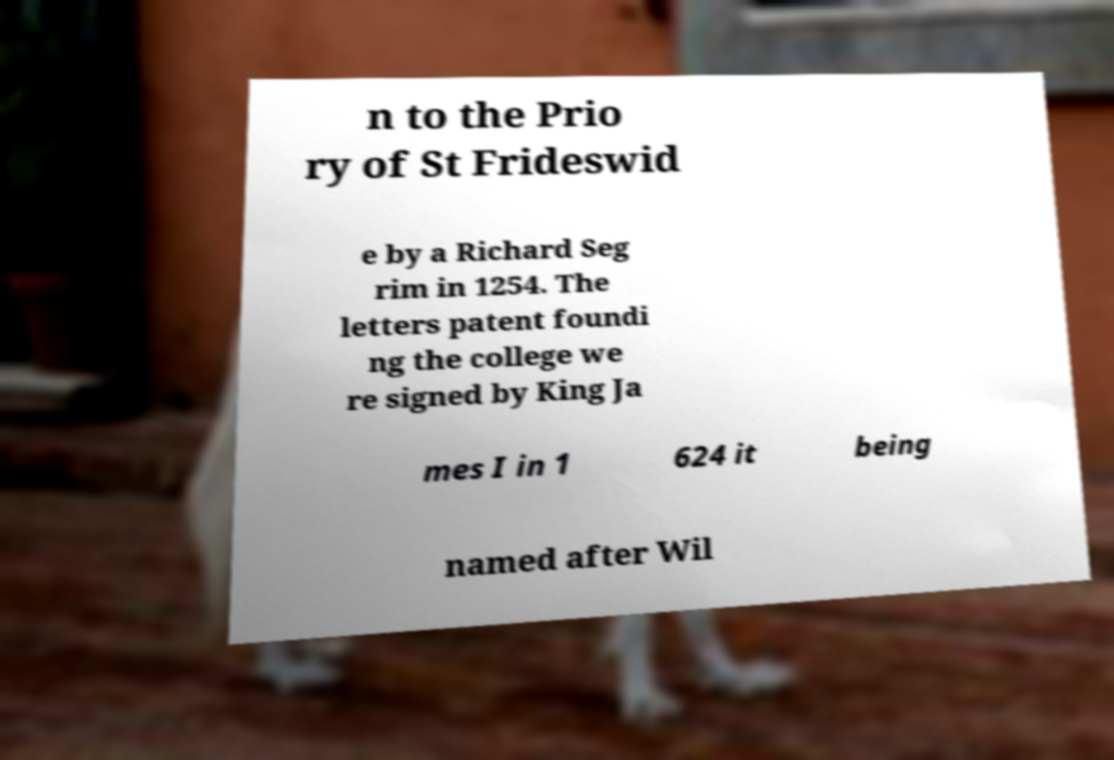There's text embedded in this image that I need extracted. Can you transcribe it verbatim? n to the Prio ry of St Frideswid e by a Richard Seg rim in 1254. The letters patent foundi ng the college we re signed by King Ja mes I in 1 624 it being named after Wil 